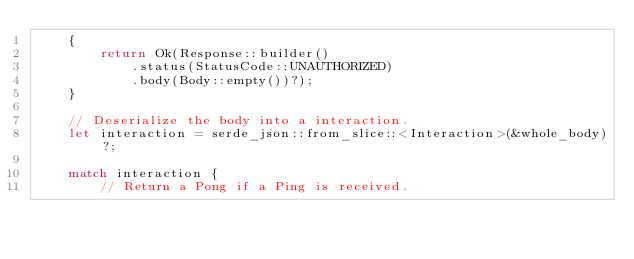<code> <loc_0><loc_0><loc_500><loc_500><_Rust_>    {
        return Ok(Response::builder()
            .status(StatusCode::UNAUTHORIZED)
            .body(Body::empty())?);
    }

    // Deserialize the body into a interaction.
    let interaction = serde_json::from_slice::<Interaction>(&whole_body)?;

    match interaction {
        // Return a Pong if a Ping is received.</code> 